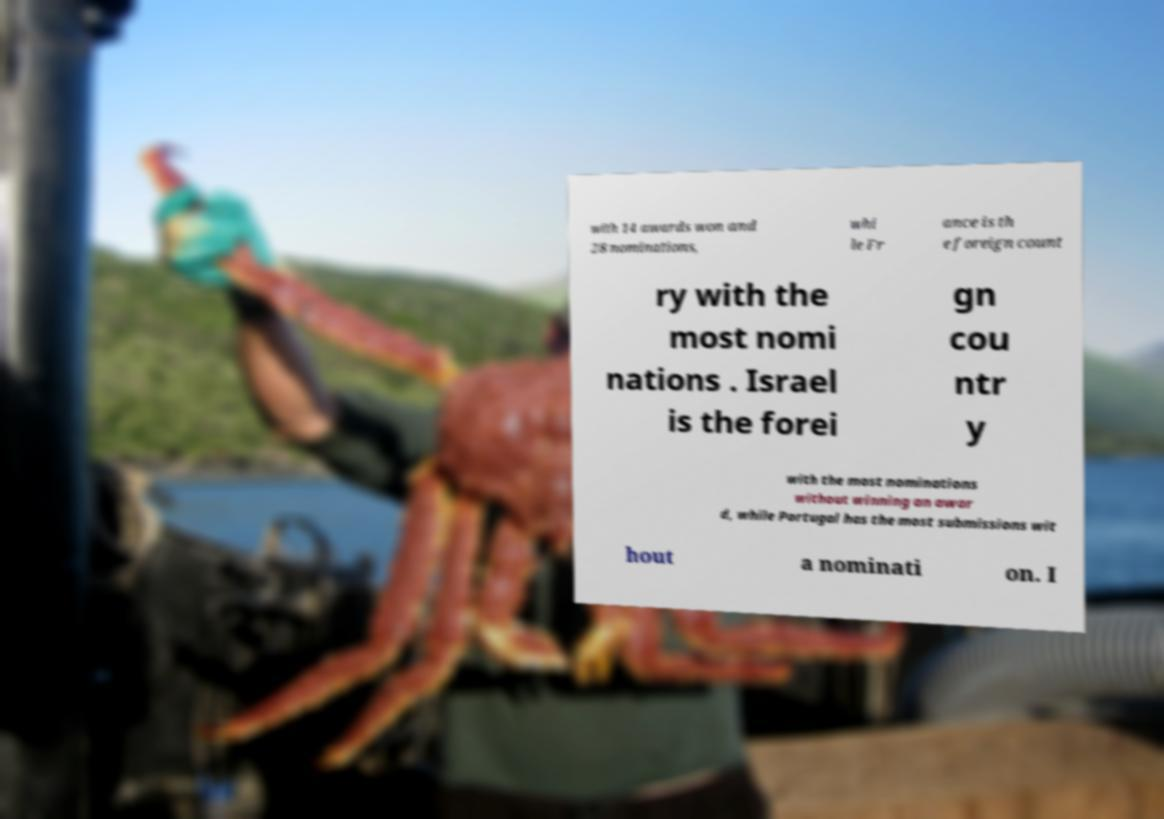I need the written content from this picture converted into text. Can you do that? with 14 awards won and 28 nominations, whi le Fr ance is th e foreign count ry with the most nomi nations . Israel is the forei gn cou ntr y with the most nominations without winning an awar d, while Portugal has the most submissions wit hout a nominati on. I 